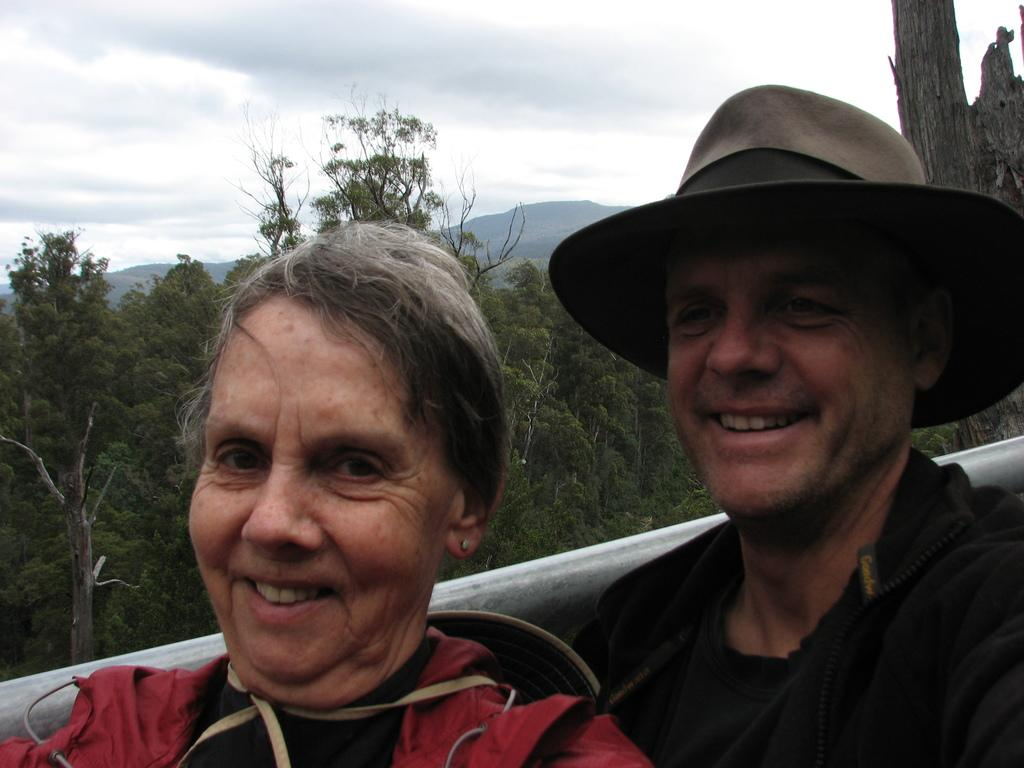How many people are in the image? There are persons in the image, but the exact number cannot be determined from the provided facts. What object can be seen in the image besides the persons? There is a rod in the image. What type of natural scenery is visible in the background of the image? There are trees and a mountain in the background of the image. What part of the natural environment is visible in the image? The sky is visible in the background of the image. What type of bell can be seen in the image? There is no bell present in the image. What design is featured on the persons' clothing in the image? The provided facts do not mention any specific design on the persons' clothing. 